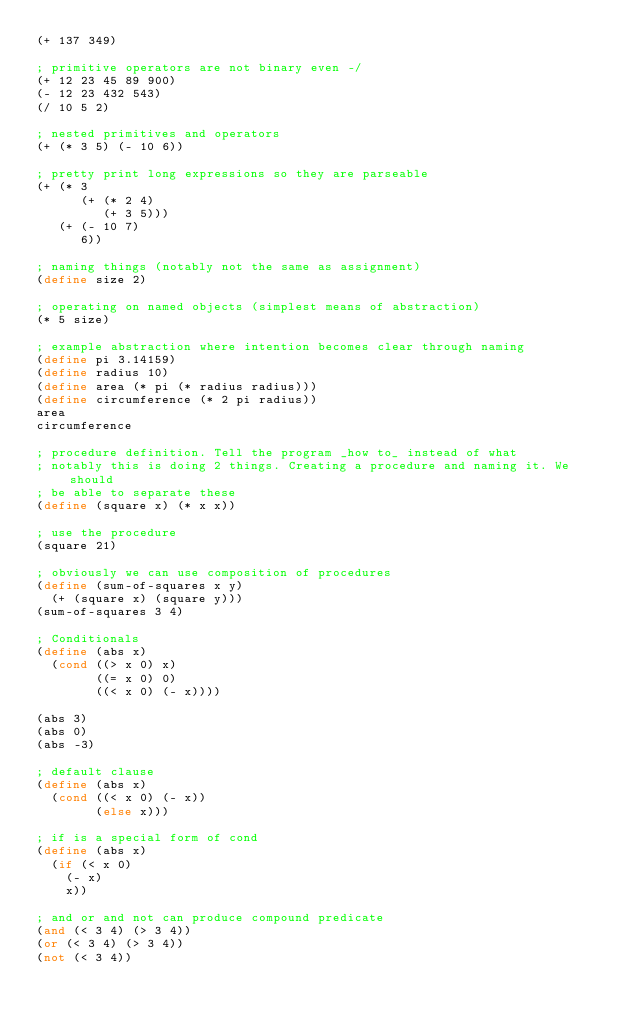<code> <loc_0><loc_0><loc_500><loc_500><_Scheme_>(+ 137 349)

; primitive operators are not binary even -/
(+ 12 23 45 89 900)
(- 12 23 432 543)
(/ 10 5 2)

; nested primitives and operators
(+ (* 3 5) (- 10 6))

; pretty print long expressions so they are parseable
(+ (* 3
      (+ (* 2 4)
         (+ 3 5)))
   (+ (- 10 7)
      6))

; naming things (notably not the same as assignment)
(define size 2)

; operating on named objects (simplest means of abstraction)
(* 5 size)

; example abstraction where intention becomes clear through naming
(define pi 3.14159)
(define radius 10)
(define area (* pi (* radius radius)))
(define circumference (* 2 pi radius))
area
circumference

; procedure definition. Tell the program _how to_ instead of what
; notably this is doing 2 things. Creating a procedure and naming it. We should
; be able to separate these
(define (square x) (* x x))

; use the procedure
(square 21)

; obviously we can use composition of procedures
(define (sum-of-squares x y)
  (+ (square x) (square y)))
(sum-of-squares 3 4)

; Conditionals
(define (abs x)
  (cond ((> x 0) x)
        ((= x 0) 0)
        ((< x 0) (- x))))

(abs 3)
(abs 0)
(abs -3)

; default clause
(define (abs x)
  (cond ((< x 0) (- x))
        (else x)))

; if is a special form of cond
(define (abs x)
  (if (< x 0)
    (- x)
    x))

; and or and not can produce compound predicate
(and (< 3 4) (> 3 4))
(or (< 3 4) (> 3 4))
(not (< 3 4))
</code> 